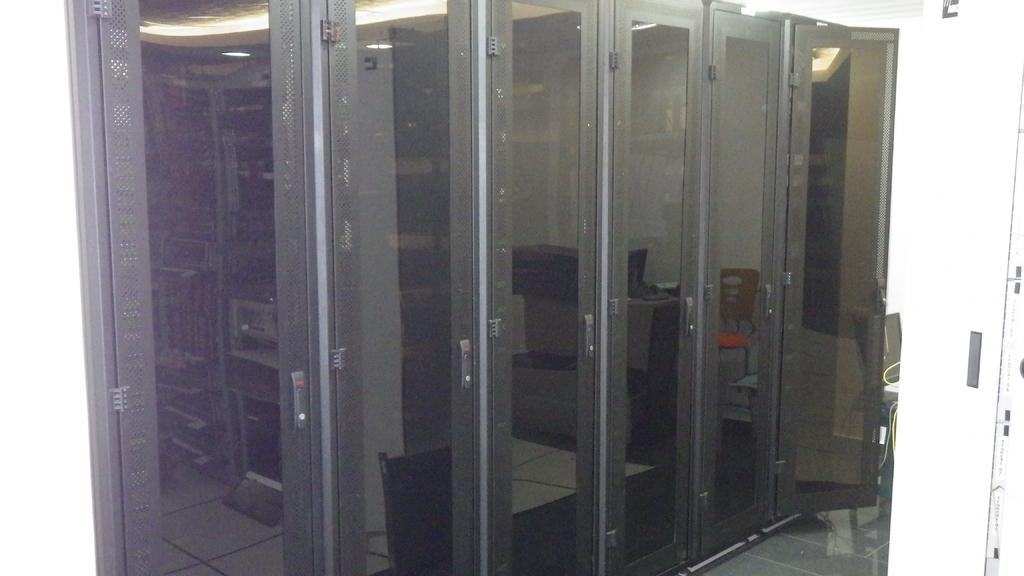What type of doors are visible in the image? There are glass doors in the image. What can be seen reflected on the glass doors? There is a reflection of a chair and a table on the glass doors. Is there a bulb sparking on the rifle in the image? There is no rifle or bulb present in the image. 